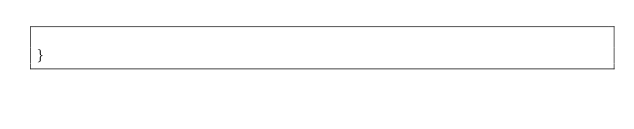Convert code to text. <code><loc_0><loc_0><loc_500><loc_500><_CSS_>
}</code> 